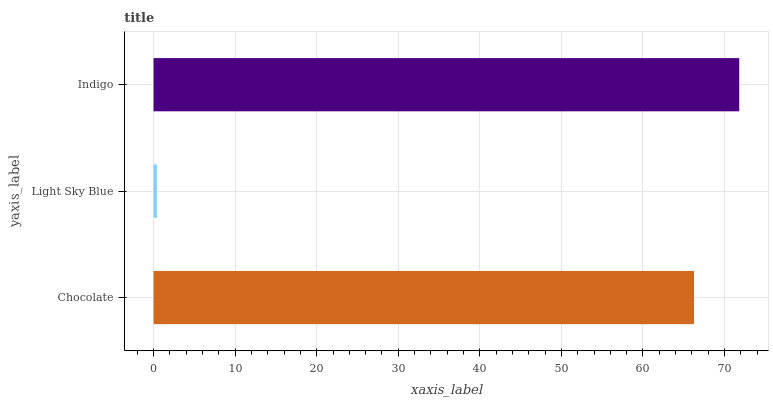Is Light Sky Blue the minimum?
Answer yes or no. Yes. Is Indigo the maximum?
Answer yes or no. Yes. Is Indigo the minimum?
Answer yes or no. No. Is Light Sky Blue the maximum?
Answer yes or no. No. Is Indigo greater than Light Sky Blue?
Answer yes or no. Yes. Is Light Sky Blue less than Indigo?
Answer yes or no. Yes. Is Light Sky Blue greater than Indigo?
Answer yes or no. No. Is Indigo less than Light Sky Blue?
Answer yes or no. No. Is Chocolate the high median?
Answer yes or no. Yes. Is Chocolate the low median?
Answer yes or no. Yes. Is Indigo the high median?
Answer yes or no. No. Is Light Sky Blue the low median?
Answer yes or no. No. 